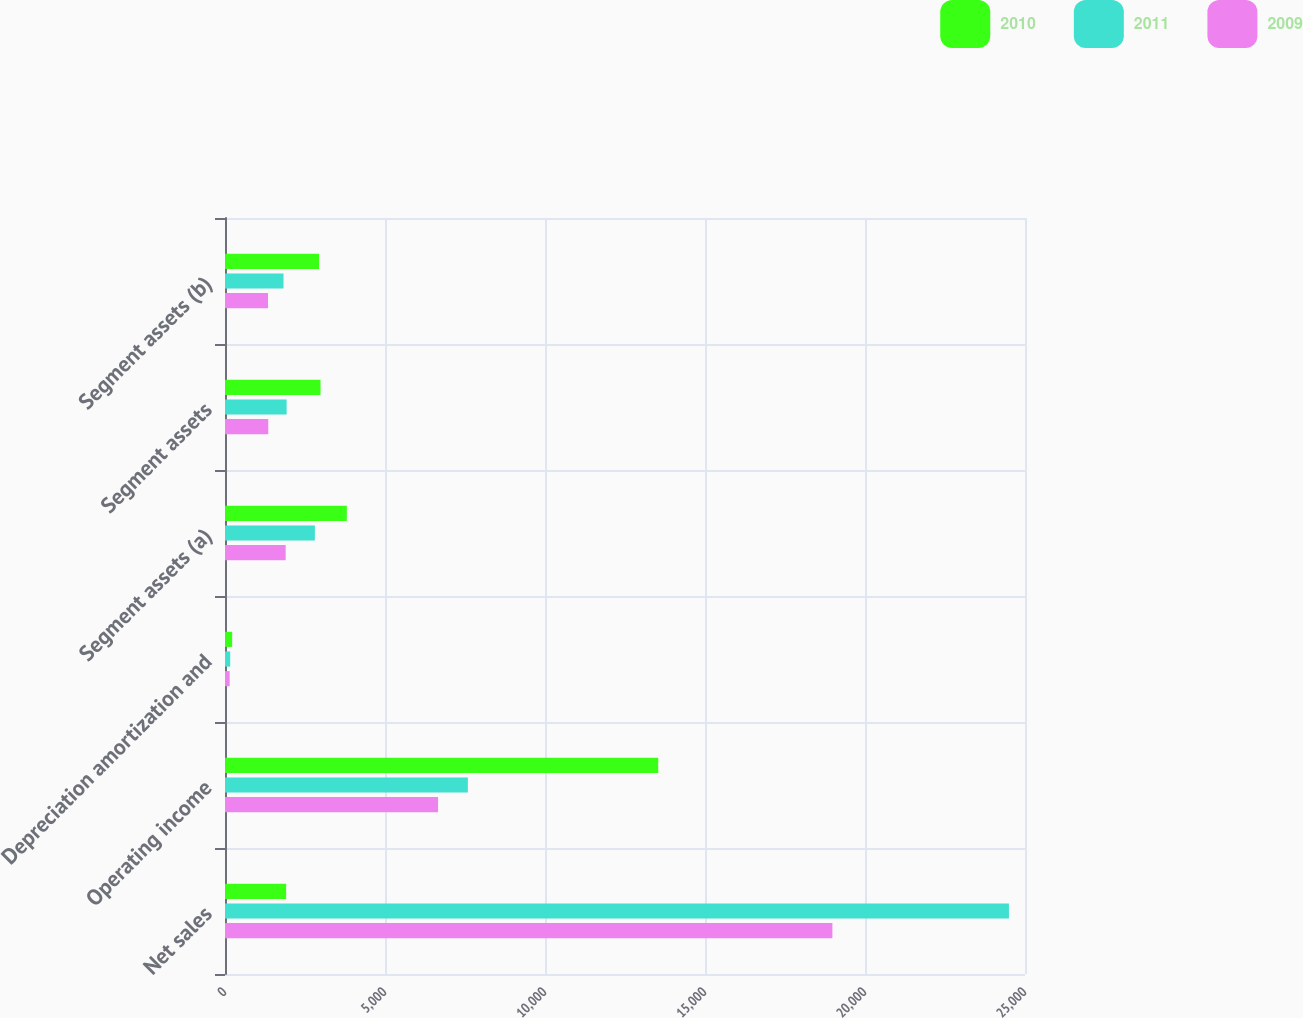Convert chart to OTSL. <chart><loc_0><loc_0><loc_500><loc_500><stacked_bar_chart><ecel><fcel>Net sales<fcel>Operating income<fcel>Depreciation amortization and<fcel>Segment assets (a)<fcel>Segment assets<fcel>Segment assets (b)<nl><fcel>2010<fcel>1911<fcel>13538<fcel>223<fcel>3807<fcel>2985<fcel>2940<nl><fcel>2011<fcel>24498<fcel>7590<fcel>163<fcel>2809<fcel>1926<fcel>1829<nl><fcel>2009<fcel>18981<fcel>6658<fcel>146<fcel>1896<fcel>1352<fcel>1344<nl></chart> 